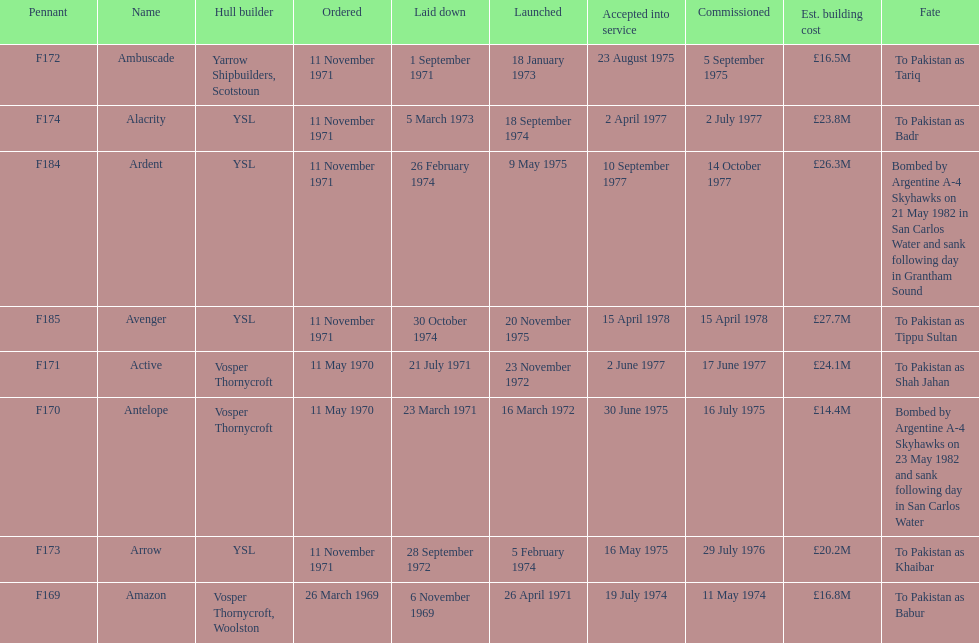Parse the table in full. {'header': ['Pennant', 'Name', 'Hull builder', 'Ordered', 'Laid down', 'Launched', 'Accepted into service', 'Commissioned', 'Est. building cost', 'Fate'], 'rows': [['F172', 'Ambuscade', 'Yarrow Shipbuilders, Scotstoun', '11 November 1971', '1 September 1971', '18 January 1973', '23 August 1975', '5 September 1975', '£16.5M', 'To Pakistan as Tariq'], ['F174', 'Alacrity', 'YSL', '11 November 1971', '5 March 1973', '18 September 1974', '2 April 1977', '2 July 1977', '£23.8M', 'To Pakistan as Badr'], ['F184', 'Ardent', 'YSL', '11 November 1971', '26 February 1974', '9 May 1975', '10 September 1977', '14 October 1977', '£26.3M', 'Bombed by Argentine A-4 Skyhawks on 21 May 1982 in San Carlos Water and sank following day in Grantham Sound'], ['F185', 'Avenger', 'YSL', '11 November 1971', '30 October 1974', '20 November 1975', '15 April 1978', '15 April 1978', '£27.7M', 'To Pakistan as Tippu Sultan'], ['F171', 'Active', 'Vosper Thornycroft', '11 May 1970', '21 July 1971', '23 November 1972', '2 June 1977', '17 June 1977', '£24.1M', 'To Pakistan as Shah Jahan'], ['F170', 'Antelope', 'Vosper Thornycroft', '11 May 1970', '23 March 1971', '16 March 1972', '30 June 1975', '16 July 1975', '£14.4M', 'Bombed by Argentine A-4 Skyhawks on 23 May 1982 and sank following day in San Carlos Water'], ['F173', 'Arrow', 'YSL', '11 November 1971', '28 September 1972', '5 February 1974', '16 May 1975', '29 July 1976', '£20.2M', 'To Pakistan as Khaibar'], ['F169', 'Amazon', 'Vosper Thornycroft, Woolston', '26 March 1969', '6 November 1969', '26 April 1971', '19 July 1974', '11 May 1974', '£16.8M', 'To Pakistan as Babur']]} During september, how many ships were set for construction? 2. 